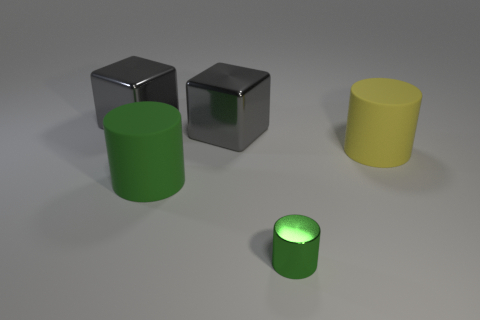Does the thing to the right of the green metal thing have the same size as the green shiny object?
Provide a succinct answer. No. There is a big gray shiny object that is on the right side of the matte thing that is left of the yellow rubber cylinder; how many gray metallic objects are left of it?
Make the answer very short. 1. How many gray things are either big matte things or big cubes?
Keep it short and to the point. 2. The other large thing that is made of the same material as the big green thing is what color?
Your answer should be compact. Yellow. Is there any other thing that is the same size as the green shiny cylinder?
Provide a short and direct response. No. What number of tiny objects are yellow matte cylinders or yellow shiny cubes?
Make the answer very short. 0. Are there fewer tiny things than tiny cyan spheres?
Make the answer very short. No. What color is the other large thing that is the same shape as the large green matte object?
Make the answer very short. Yellow. Is the number of yellow cylinders greater than the number of large blue shiny blocks?
Offer a terse response. Yes. How many other things are there of the same material as the big yellow cylinder?
Provide a short and direct response. 1. 